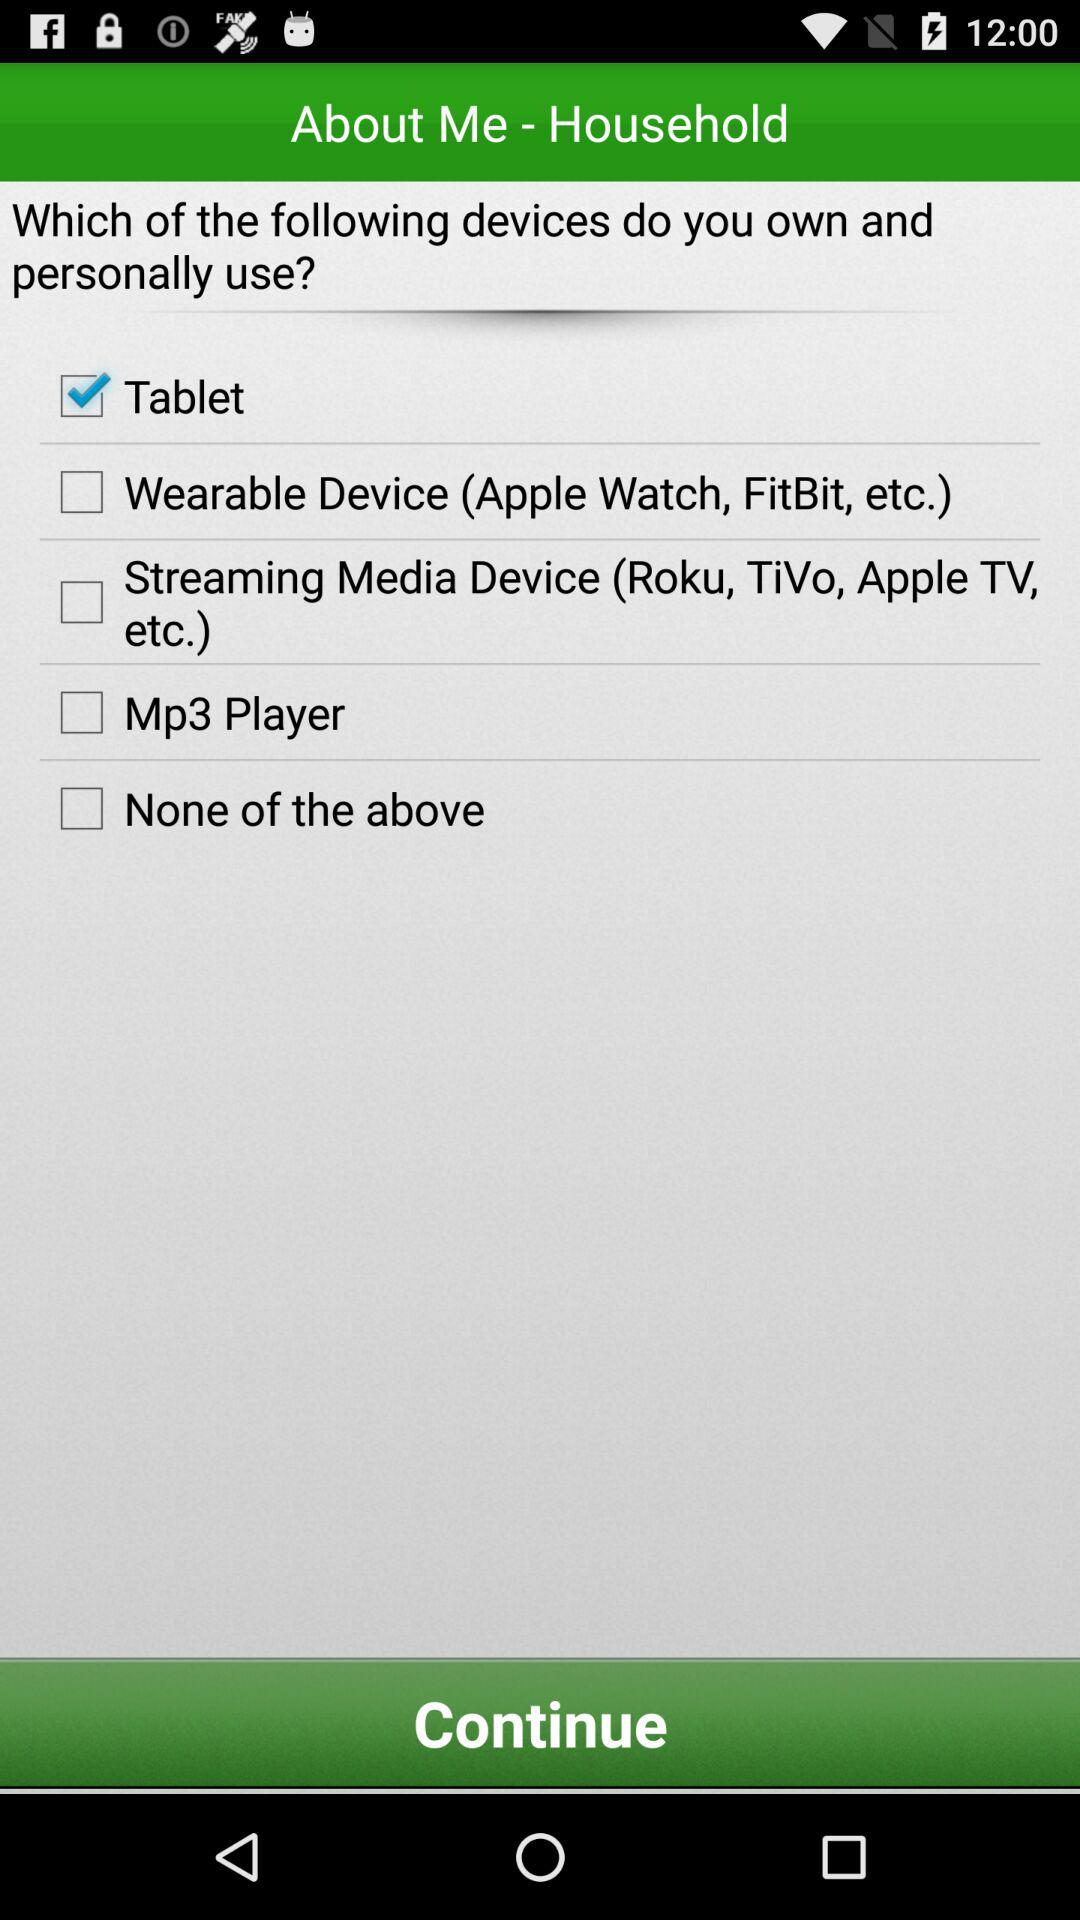How many devices can you choose to indicate that you own and personally use?
Answer the question using a single word or phrase. 5 